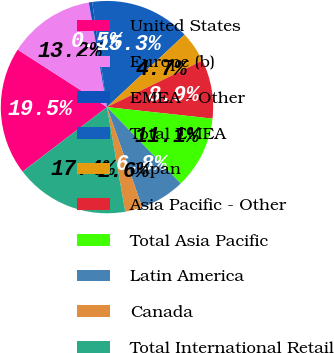Convert chart to OTSL. <chart><loc_0><loc_0><loc_500><loc_500><pie_chart><fcel>United States<fcel>Europe (b)<fcel>EMEA - Other<fcel>Total EMEA<fcel>Japan<fcel>Asia Pacific - Other<fcel>Total Asia Pacific<fcel>Latin America<fcel>Canada<fcel>Total International Retail<nl><fcel>19.48%<fcel>13.16%<fcel>0.52%<fcel>15.27%<fcel>4.73%<fcel>8.95%<fcel>11.05%<fcel>6.84%<fcel>2.63%<fcel>17.37%<nl></chart> 